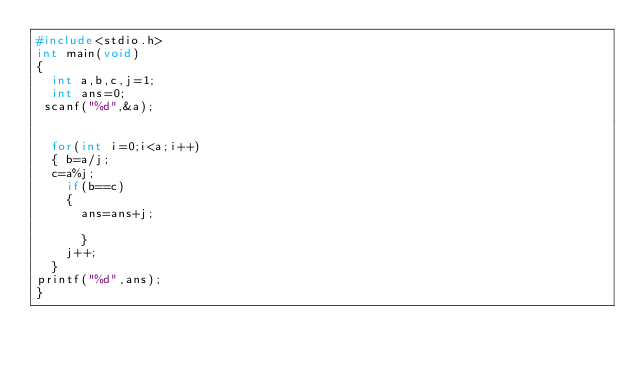<code> <loc_0><loc_0><loc_500><loc_500><_C_>#include<stdio.h>
int main(void)
{
  int a,b,c,j=1;
  int ans=0;
 scanf("%d",&a);
  
 
  for(int i=0;i<a;i++)
  { b=a/j;
  c=a%j;
    if(b==c)
    {  
      ans=ans+j;
   
      }
    j++;
  }
printf("%d",ans);
}</code> 